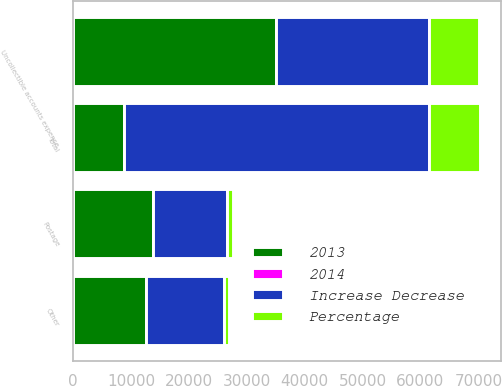<chart> <loc_0><loc_0><loc_500><loc_500><stacked_bar_chart><ecel><fcel>Uncollectible accounts expense<fcel>Postage<fcel>Other<fcel>Total<nl><fcel>2013<fcel>35027<fcel>13793<fcel>12639<fcel>8834<nl><fcel>Increase Decrease<fcel>26443<fcel>12757<fcel>13425<fcel>52625<nl><fcel>Percentage<fcel>8584<fcel>1036<fcel>786<fcel>8834<nl><fcel>2014<fcel>32.5<fcel>8.1<fcel>5.9<fcel>16.8<nl></chart> 